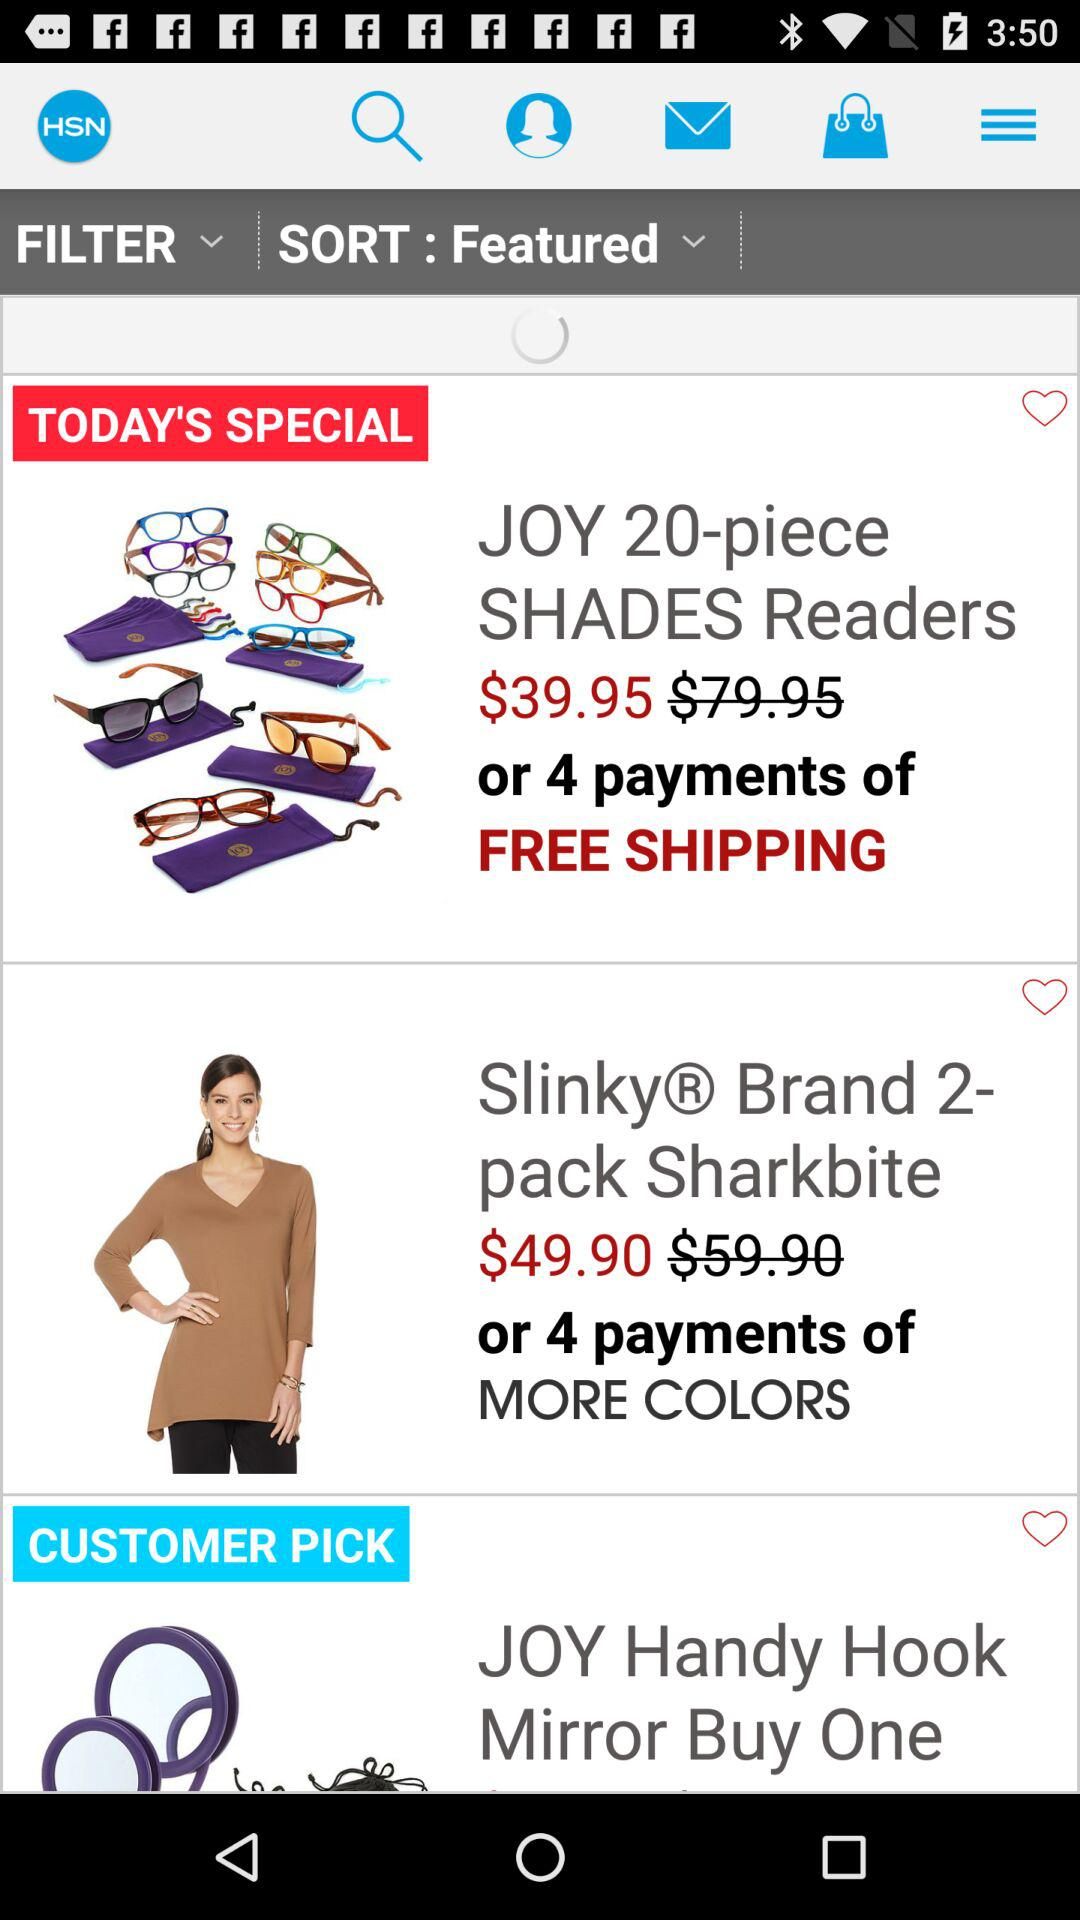How many items are featured on the page?
Answer the question using a single word or phrase. 3 